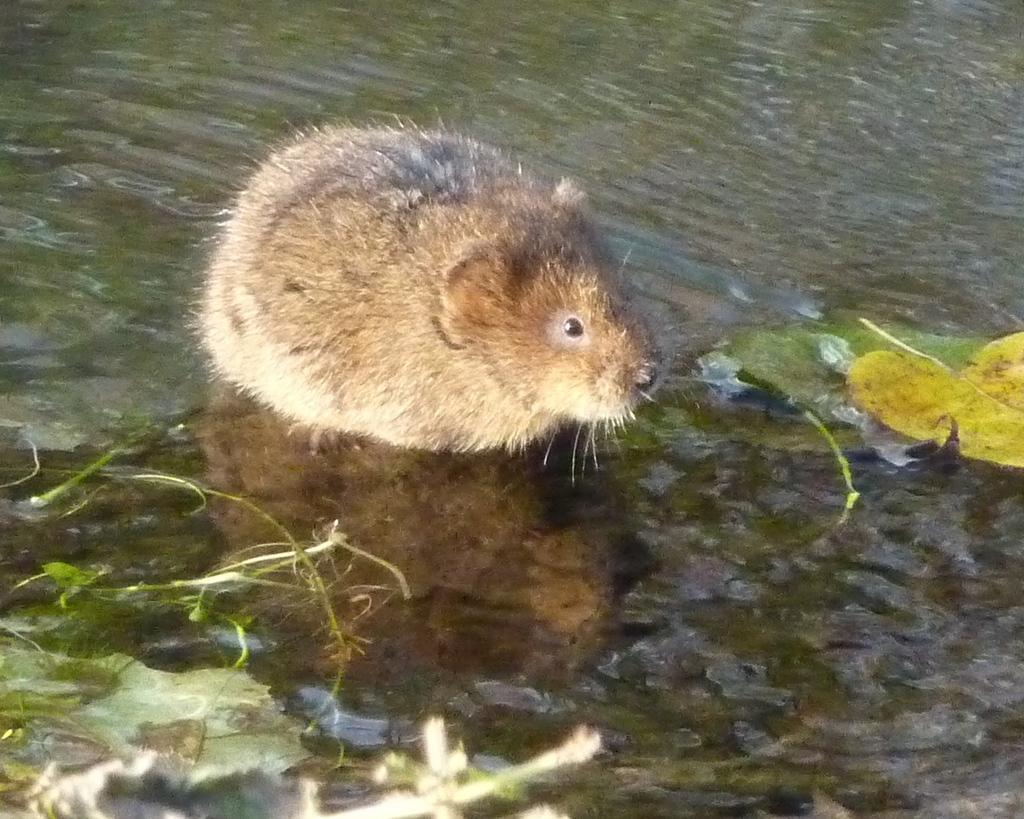How would you summarize this image in a sentence or two? In this picture, it looks like a rat and the rat is standing in the water. In front of the rat there are leaves and stems. 